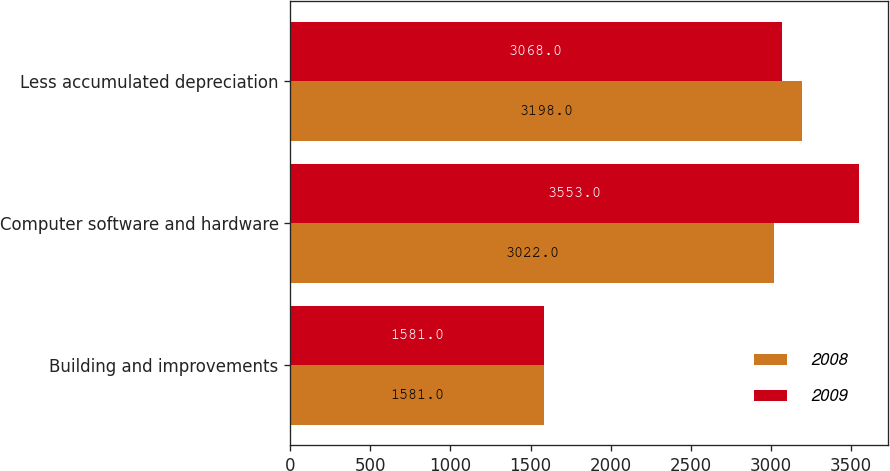<chart> <loc_0><loc_0><loc_500><loc_500><stacked_bar_chart><ecel><fcel>Building and improvements<fcel>Computer software and hardware<fcel>Less accumulated depreciation<nl><fcel>2008<fcel>1581<fcel>3022<fcel>3198<nl><fcel>2009<fcel>1581<fcel>3553<fcel>3068<nl></chart> 